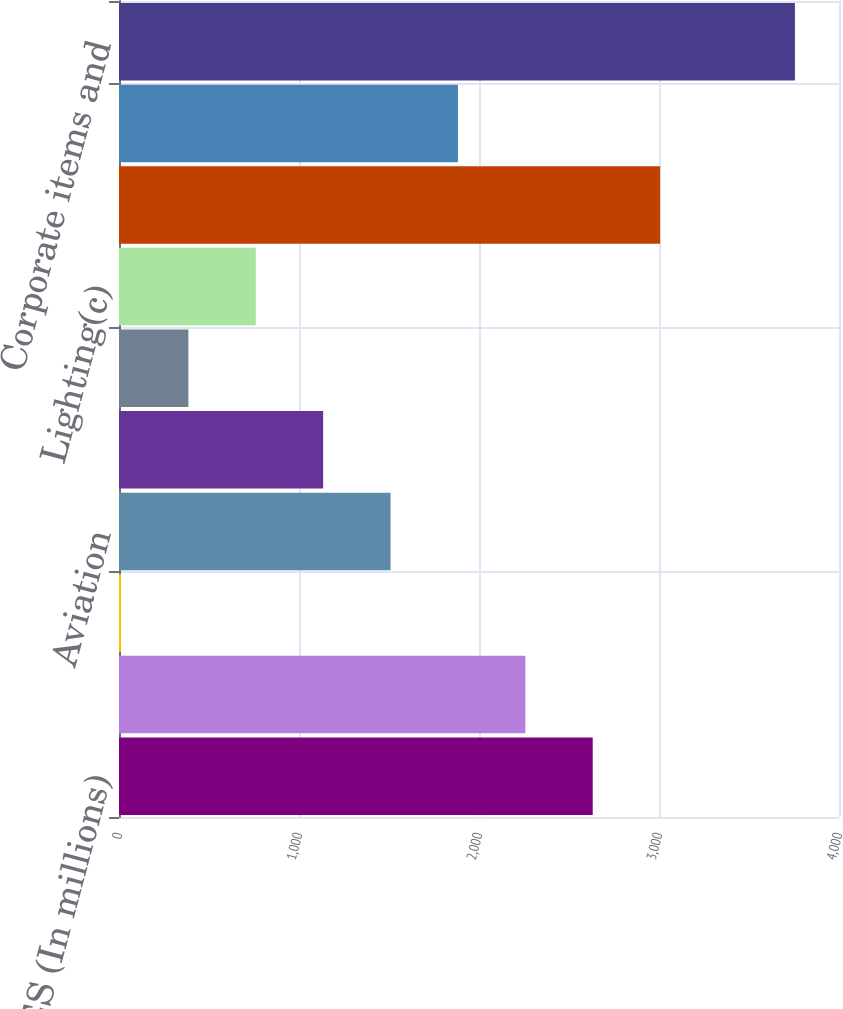Convert chart. <chart><loc_0><loc_0><loc_500><loc_500><bar_chart><fcel>REVENUES (In millions)<fcel>Power<fcel>Renewable Energy<fcel>Aviation<fcel>Oil & Gas<fcel>Healthcare<fcel>Lighting(c)<fcel>Total industrial segment<fcel>Capital<fcel>Corporate items and<nl><fcel>2631.8<fcel>2257.4<fcel>11<fcel>1508.6<fcel>1134.2<fcel>385.4<fcel>759.8<fcel>3006.2<fcel>1883<fcel>3755<nl></chart> 